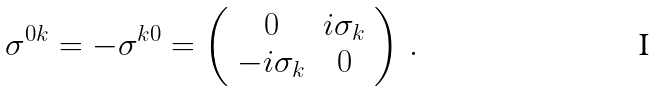<formula> <loc_0><loc_0><loc_500><loc_500>\sigma ^ { 0 k } = - \sigma ^ { k 0 } = \left ( \begin{array} { * { 2 } { c } } 0 & i \sigma _ { k } \\ - i \sigma _ { k } & 0 \end{array} \right ) \, .</formula> 